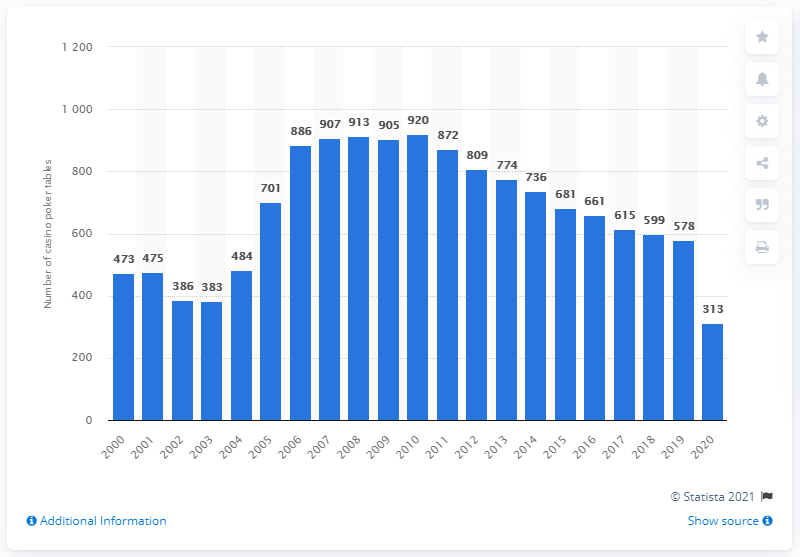Outline some significant characteristics in this image. In 2010, there were 578 poker tables in casinos in Nevada. In 2020, there were 313 poker tables available in casinos in Nevada. Since the year 2010, the number of casino poker tables in Nevada has been declining. 